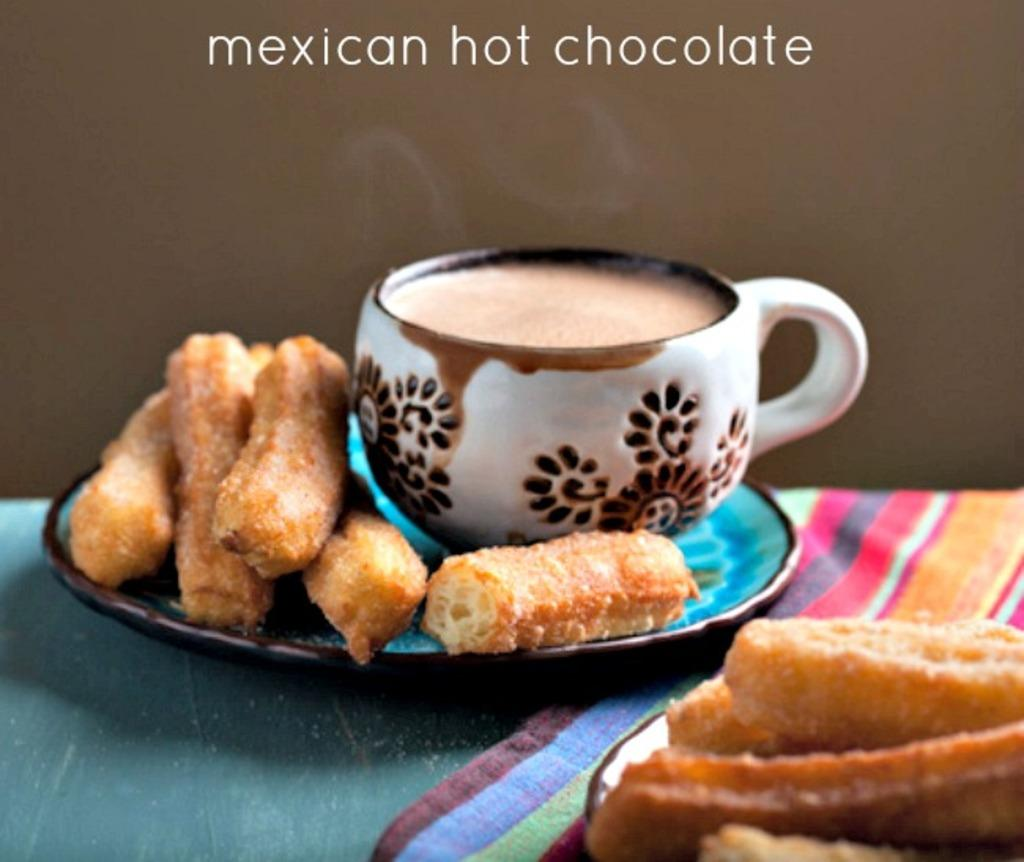What is in the cup that is visible in the image? There is a drink in a cup in the image. What other items can be seen near the drink? There are snacks beside the drink in the image. Can you tell me the name of the food item mentioned above the picture? Unfortunately, the provided facts do not mention the name of the food item. What type of scarf is being used to hold the drink in the image? There is no scarf present in the image, and the drink is not being held by any scarf. How is the milk being used in the image? There is no milk present in the image, so it cannot be used in any way. 